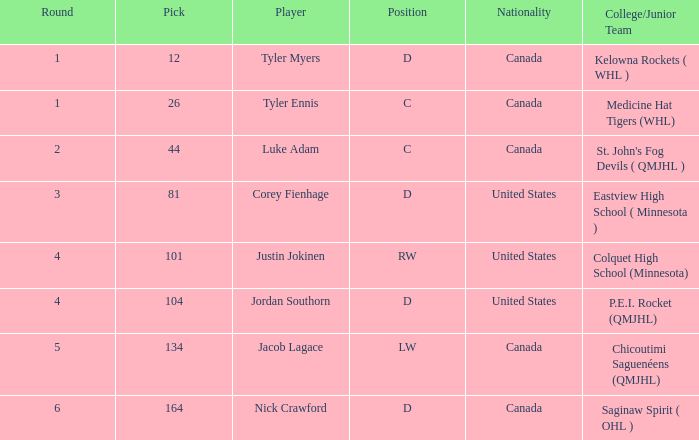What is the citizenship of athlete corey fienhage, who has a selection below 104? United States. 